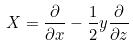Convert formula to latex. <formula><loc_0><loc_0><loc_500><loc_500>X = \frac { \partial } { \partial x } - \frac { 1 } { 2 } y \frac { \partial } { \partial z }</formula> 